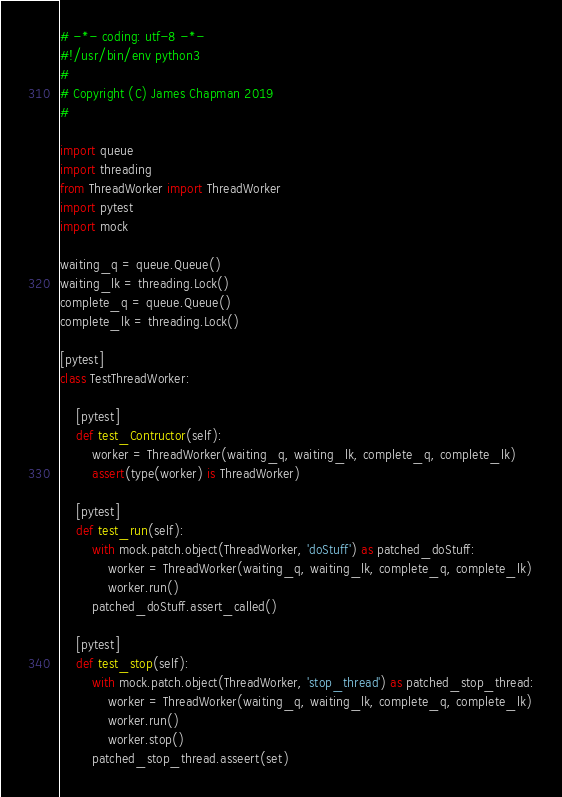<code> <loc_0><loc_0><loc_500><loc_500><_Python_># -*- coding: utf-8 -*-
#!/usr/bin/env python3
#
# Copyright (C) James Chapman 2019
#

import queue
import threading
from ThreadWorker import ThreadWorker
import pytest
import mock

waiting_q = queue.Queue()
waiting_lk = threading.Lock()
complete_q = queue.Queue()
complete_lk = threading.Lock()

[pytest]
class TestThreadWorker:

    [pytest]
    def test_Contructor(self):
        worker = ThreadWorker(waiting_q, waiting_lk, complete_q, complete_lk)
        assert(type(worker) is ThreadWorker)

    [pytest]
    def test_run(self):
        with mock.patch.object(ThreadWorker, 'doStuff') as patched_doStuff:
            worker = ThreadWorker(waiting_q, waiting_lk, complete_q, complete_lk)
            worker.run()
        patched_doStuff.assert_called()

    [pytest]
    def test_stop(self):
        with mock.patch.object(ThreadWorker, 'stop_thread') as patched_stop_thread:
            worker = ThreadWorker(waiting_q, waiting_lk, complete_q, complete_lk)
            worker.run()
            worker.stop()
        patched_stop_thread.asseert(set)
</code> 